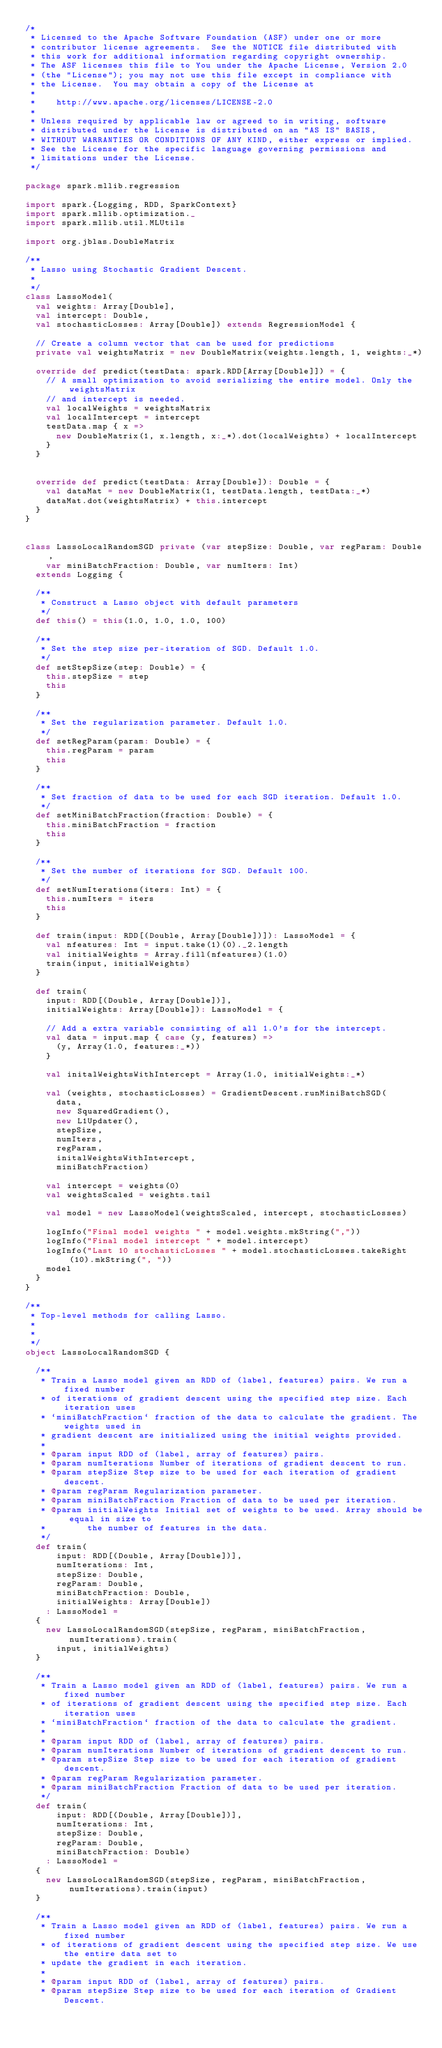<code> <loc_0><loc_0><loc_500><loc_500><_Scala_>/*
 * Licensed to the Apache Software Foundation (ASF) under one or more
 * contributor license agreements.  See the NOTICE file distributed with
 * this work for additional information regarding copyright ownership.
 * The ASF licenses this file to You under the Apache License, Version 2.0
 * (the "License"); you may not use this file except in compliance with
 * the License.  You may obtain a copy of the License at
 *
 *    http://www.apache.org/licenses/LICENSE-2.0
 *
 * Unless required by applicable law or agreed to in writing, software
 * distributed under the License is distributed on an "AS IS" BASIS,
 * WITHOUT WARRANTIES OR CONDITIONS OF ANY KIND, either express or implied.
 * See the License for the specific language governing permissions and
 * limitations under the License.
 */

package spark.mllib.regression

import spark.{Logging, RDD, SparkContext}
import spark.mllib.optimization._
import spark.mllib.util.MLUtils

import org.jblas.DoubleMatrix

/**
 * Lasso using Stochastic Gradient Descent.
 *
 */
class LassoModel(
  val weights: Array[Double],
  val intercept: Double,
  val stochasticLosses: Array[Double]) extends RegressionModel {

  // Create a column vector that can be used for predictions
  private val weightsMatrix = new DoubleMatrix(weights.length, 1, weights:_*)

  override def predict(testData: spark.RDD[Array[Double]]) = {
    // A small optimization to avoid serializing the entire model. Only the weightsMatrix
    // and intercept is needed.
    val localWeights = weightsMatrix
    val localIntercept = intercept
    testData.map { x =>
      new DoubleMatrix(1, x.length, x:_*).dot(localWeights) + localIntercept
    }
  }


  override def predict(testData: Array[Double]): Double = {
    val dataMat = new DoubleMatrix(1, testData.length, testData:_*)
    dataMat.dot(weightsMatrix) + this.intercept
  }
}


class LassoLocalRandomSGD private (var stepSize: Double, var regParam: Double,
    var miniBatchFraction: Double, var numIters: Int)
  extends Logging {

  /**
   * Construct a Lasso object with default parameters
   */
  def this() = this(1.0, 1.0, 1.0, 100)

  /**
   * Set the step size per-iteration of SGD. Default 1.0.
   */
  def setStepSize(step: Double) = {
    this.stepSize = step
    this
  }

  /**
   * Set the regularization parameter. Default 1.0.
   */
  def setRegParam(param: Double) = {
    this.regParam = param
    this
  }

  /**
   * Set fraction of data to be used for each SGD iteration. Default 1.0.
   */
  def setMiniBatchFraction(fraction: Double) = {
    this.miniBatchFraction = fraction
    this
  }

  /**
   * Set the number of iterations for SGD. Default 100.
   */
  def setNumIterations(iters: Int) = {
    this.numIters = iters
    this
  }

  def train(input: RDD[(Double, Array[Double])]): LassoModel = {
    val nfeatures: Int = input.take(1)(0)._2.length
    val initialWeights = Array.fill(nfeatures)(1.0)
    train(input, initialWeights)
  }

  def train(
    input: RDD[(Double, Array[Double])],
    initialWeights: Array[Double]): LassoModel = {

    // Add a extra variable consisting of all 1.0's for the intercept.
    val data = input.map { case (y, features) =>
      (y, Array(1.0, features:_*))
    }

    val initalWeightsWithIntercept = Array(1.0, initialWeights:_*)

    val (weights, stochasticLosses) = GradientDescent.runMiniBatchSGD(
      data,
      new SquaredGradient(),
      new L1Updater(),
      stepSize,
      numIters,
      regParam,
      initalWeightsWithIntercept,
      miniBatchFraction)

    val intercept = weights(0)
    val weightsScaled = weights.tail

    val model = new LassoModel(weightsScaled, intercept, stochasticLosses)

    logInfo("Final model weights " + model.weights.mkString(","))
    logInfo("Final model intercept " + model.intercept)
    logInfo("Last 10 stochasticLosses " + model.stochasticLosses.takeRight(10).mkString(", "))
    model
  }
}

/**
 * Top-level methods for calling Lasso.
 *
 *
 */
object LassoLocalRandomSGD {

  /**
   * Train a Lasso model given an RDD of (label, features) pairs. We run a fixed number
   * of iterations of gradient descent using the specified step size. Each iteration uses
   * `miniBatchFraction` fraction of the data to calculate the gradient. The weights used in
   * gradient descent are initialized using the initial weights provided.
   *
   * @param input RDD of (label, array of features) pairs.
   * @param numIterations Number of iterations of gradient descent to run.
   * @param stepSize Step size to be used for each iteration of gradient descent.
   * @param regParam Regularization parameter.
   * @param miniBatchFraction Fraction of data to be used per iteration.
   * @param initialWeights Initial set of weights to be used. Array should be equal in size to 
   *        the number of features in the data.
   */
  def train(
      input: RDD[(Double, Array[Double])],
      numIterations: Int,
      stepSize: Double,
      regParam: Double,
      miniBatchFraction: Double,
      initialWeights: Array[Double])
    : LassoModel =
  {
    new LassoLocalRandomSGD(stepSize, regParam, miniBatchFraction, numIterations).train(
      input, initialWeights)
  }

  /**
   * Train a Lasso model given an RDD of (label, features) pairs. We run a fixed number
   * of iterations of gradient descent using the specified step size. Each iteration uses
   * `miniBatchFraction` fraction of the data to calculate the gradient.
   *
   * @param input RDD of (label, array of features) pairs.
   * @param numIterations Number of iterations of gradient descent to run.
   * @param stepSize Step size to be used for each iteration of gradient descent.
   * @param regParam Regularization parameter.
   * @param miniBatchFraction Fraction of data to be used per iteration.
   */
  def train(
      input: RDD[(Double, Array[Double])],
      numIterations: Int,
      stepSize: Double,
      regParam: Double,
      miniBatchFraction: Double)
    : LassoModel =
  {
    new LassoLocalRandomSGD(stepSize, regParam, miniBatchFraction, numIterations).train(input)
  }

  /**
   * Train a Lasso model given an RDD of (label, features) pairs. We run a fixed number
   * of iterations of gradient descent using the specified step size. We use the entire data set to
   * update the gradient in each iteration.
   *
   * @param input RDD of (label, array of features) pairs.
   * @param stepSize Step size to be used for each iteration of Gradient Descent.</code> 